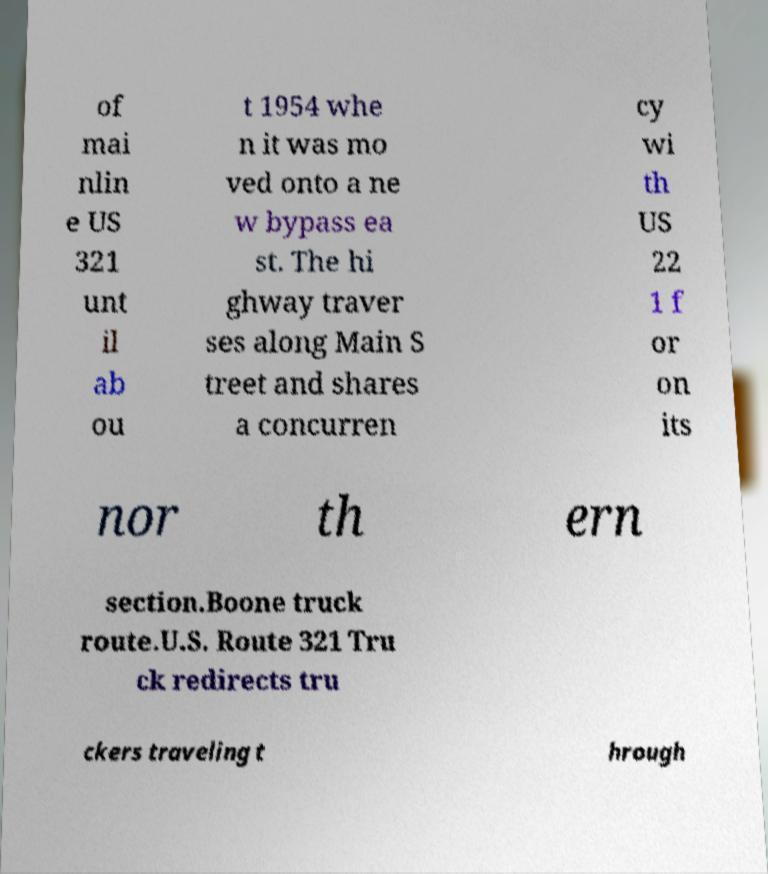Can you accurately transcribe the text from the provided image for me? of mai nlin e US 321 unt il ab ou t 1954 whe n it was mo ved onto a ne w bypass ea st. The hi ghway traver ses along Main S treet and shares a concurren cy wi th US 22 1 f or on its nor th ern section.Boone truck route.U.S. Route 321 Tru ck redirects tru ckers traveling t hrough 